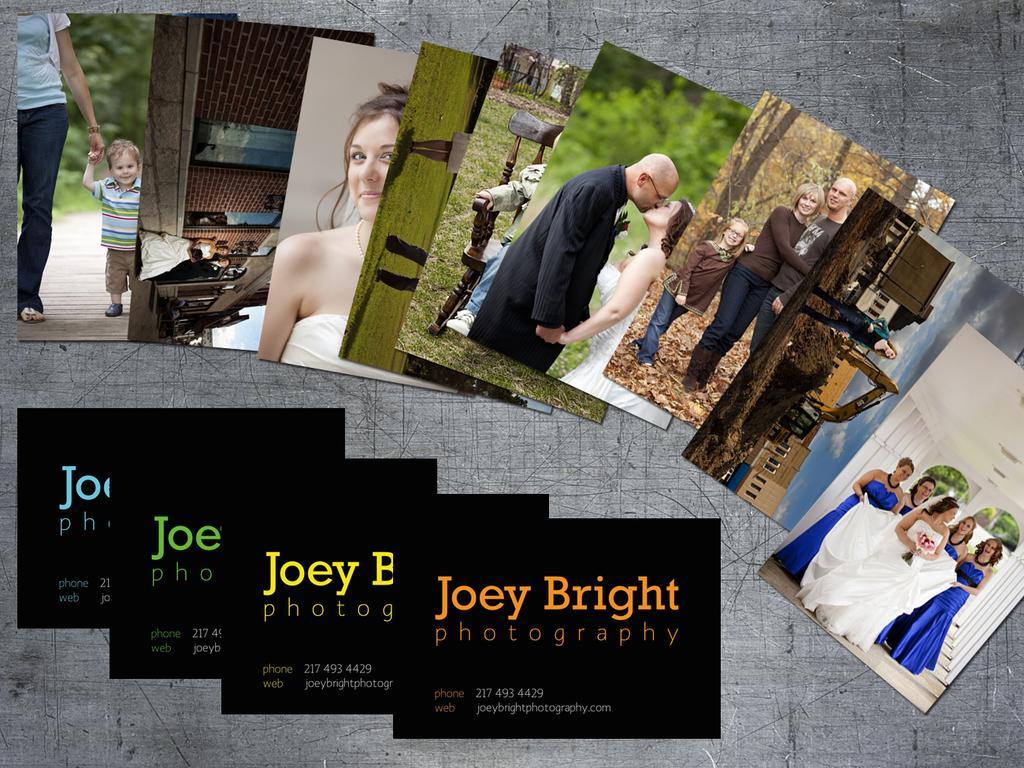In one or two sentences, can you explain what this image depicts? In this image we can see pictures of persons and something is written on it. 